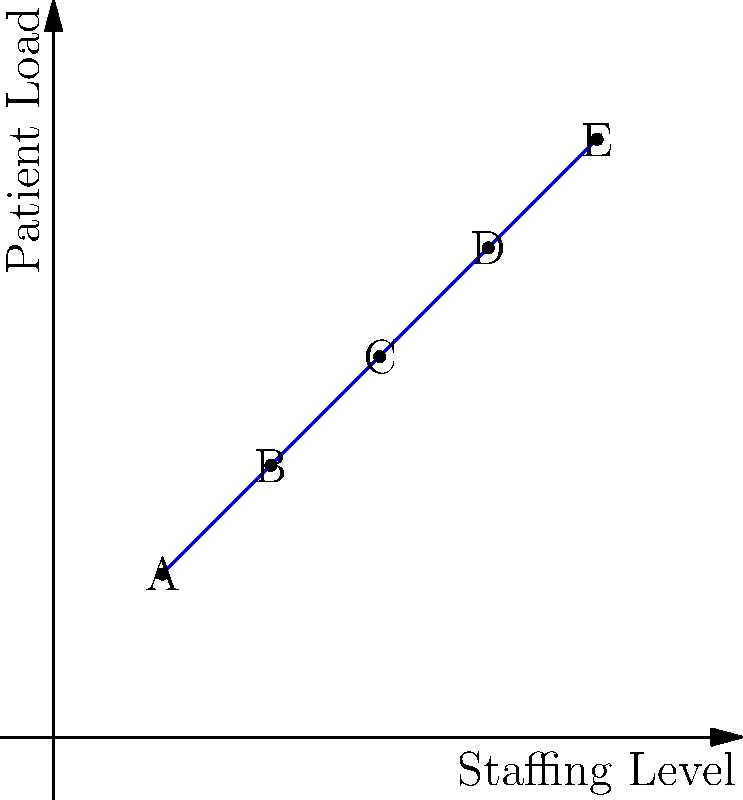Given the graph showing the relationship between staffing levels and patient loads in a healthcare facility, where points A(10, 15), B(20, 25), C(30, 35), D(40, 45), and E(50, 55) represent different operational states, calculate the vector that represents the most efficient change in resource allocation to move from point A to point D. To find the most efficient change in resource allocation from point A to point D, we need to calculate the vector connecting these two points. This can be done using vector subtraction.

Step 1: Identify the coordinates of points A and D.
A = (10, 15)
D = (40, 45)

Step 2: Calculate the vector from A to D by subtracting the coordinates of A from D.
$$\vec{AD} = D - A = (40 - 10, 45 - 15) = (30, 30)$$

Step 3: Interpret the result.
The vector (30, 30) represents the most efficient change in resource allocation to move from point A to point D. This means:
- Increase staffing level by 30 units
- Increase patient load capacity by 30 units

The efficiency of this allocation is evident as it moves along the diagonal of the graph, maintaining a balanced ratio between staffing and patient load.
Answer: (30, 30) 